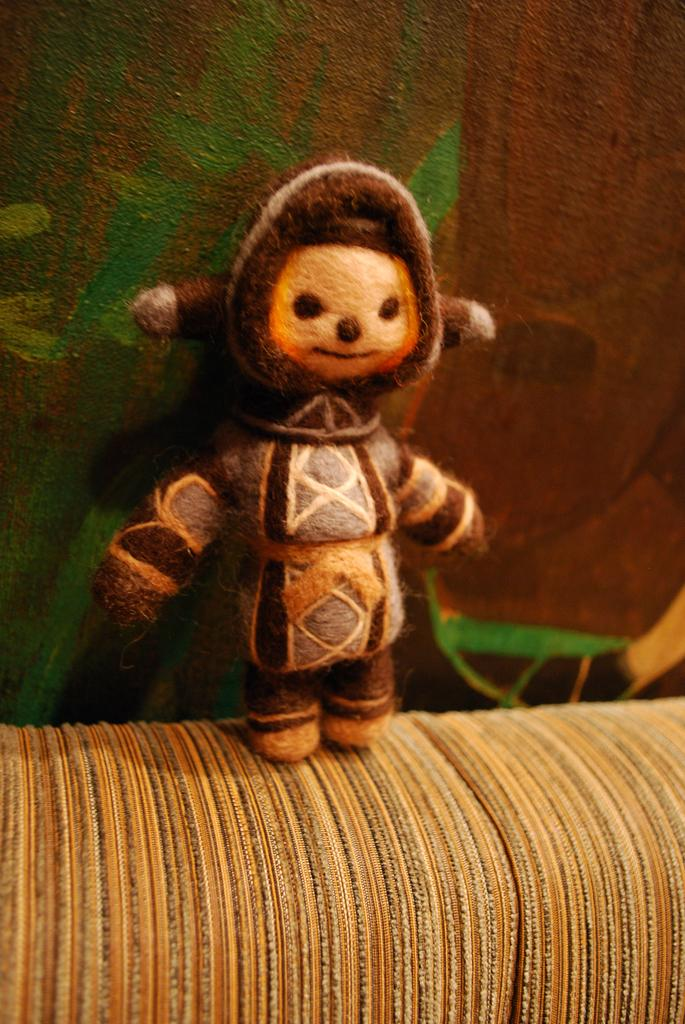What is the main subject of the image? There is a doll in the image. Where is the doll located? The doll is on a sofa. What is the color of the doll? The doll is brown in color. What can be seen in the background of the image? There is a wall in the background of the image. What is the color of the wall? The wall is green in color. What type of quartz can be seen in the image? There is no quartz present in the image. Is the wire holding the doll in place in the image? There is no wire visible in the image, and the doll is sitting on the sofa, not being held in place by any wire. 